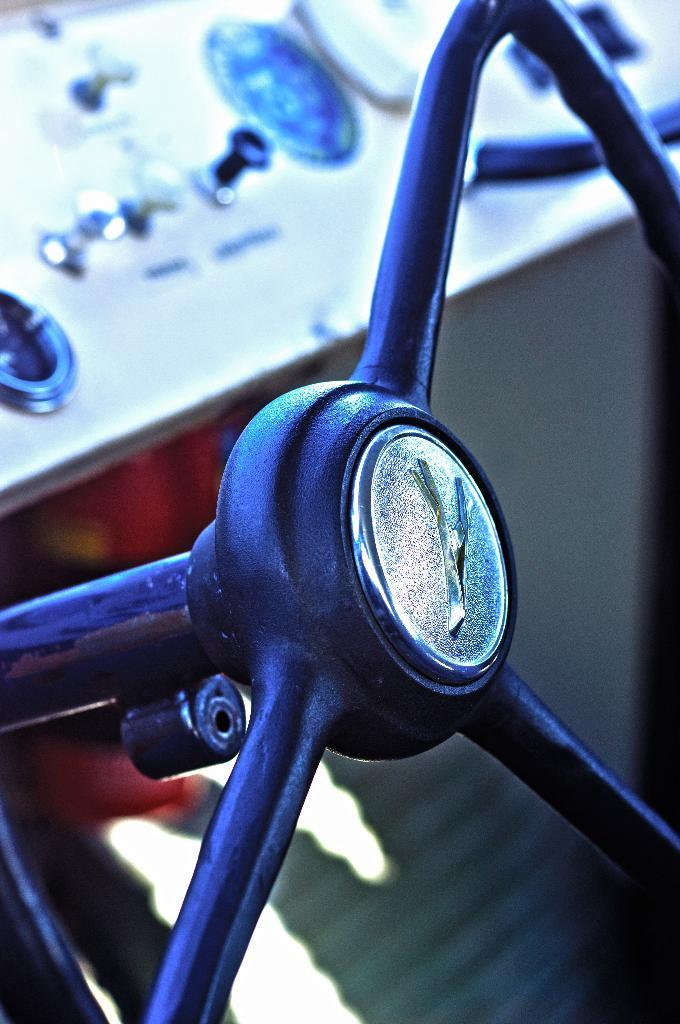What type of vehicle is shown in the image? The image depicts a vehicle, but the specific type is not mentioned in the facts. What is used to control the direction of the vehicle? There is a steering wheel in the vehicle. What type of controls are present in the vehicle? There are knobs in the vehicle. What information is displayed in the vehicle? There are meter readings in the vehicle. What type of tree can be seen growing through the roof of the vehicle in the image? There is no tree growing through the roof of the vehicle in the image. Can you hear the sound of waves crashing in the background of the image? There is no sound mentioned in the image. Is there a guitar visible in the image? There is no guitar visible in the image. 